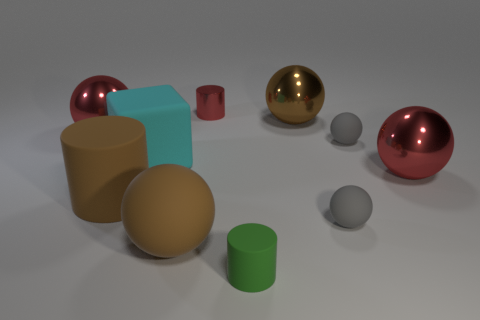What material do the shiny spheres look like they're made of? The shiny spheres have a reflective surface that suggests they are made of a polished metallic material, giving them a lustrous appearance similar to highly polished metals. 